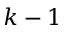Convert formula to latex. <formula><loc_0><loc_0><loc_500><loc_500>k - 1</formula> 